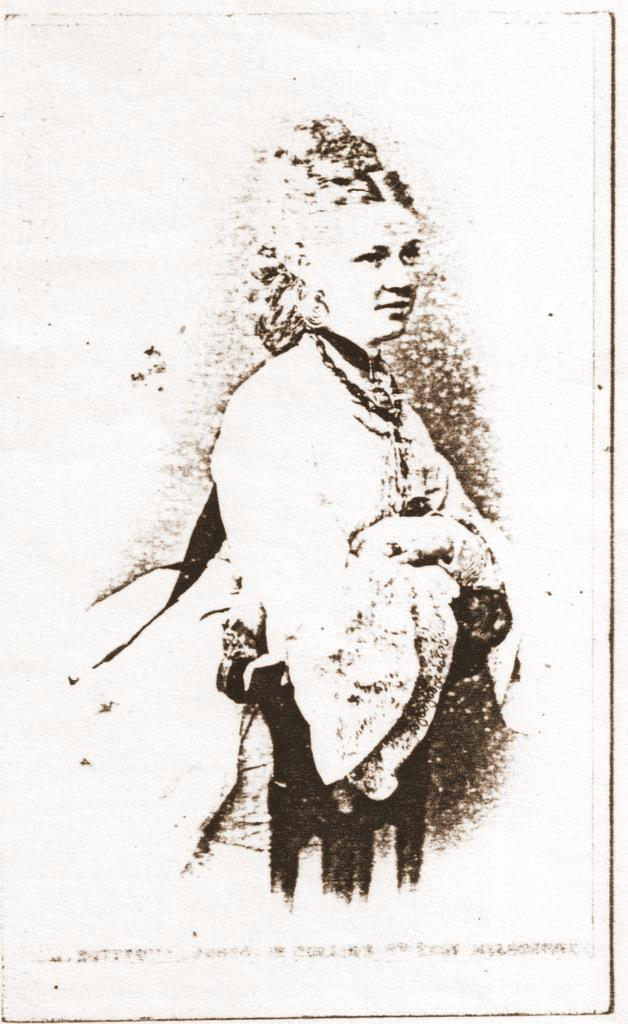What is depicted in the image? There is a sketch of a person in the image. What is the medium of the sketch? The sketch is on a piece of paper. How many pies are being sold at the door in the image? There is no door or pies present in the image; it only features a sketch of a person on a piece of paper. 